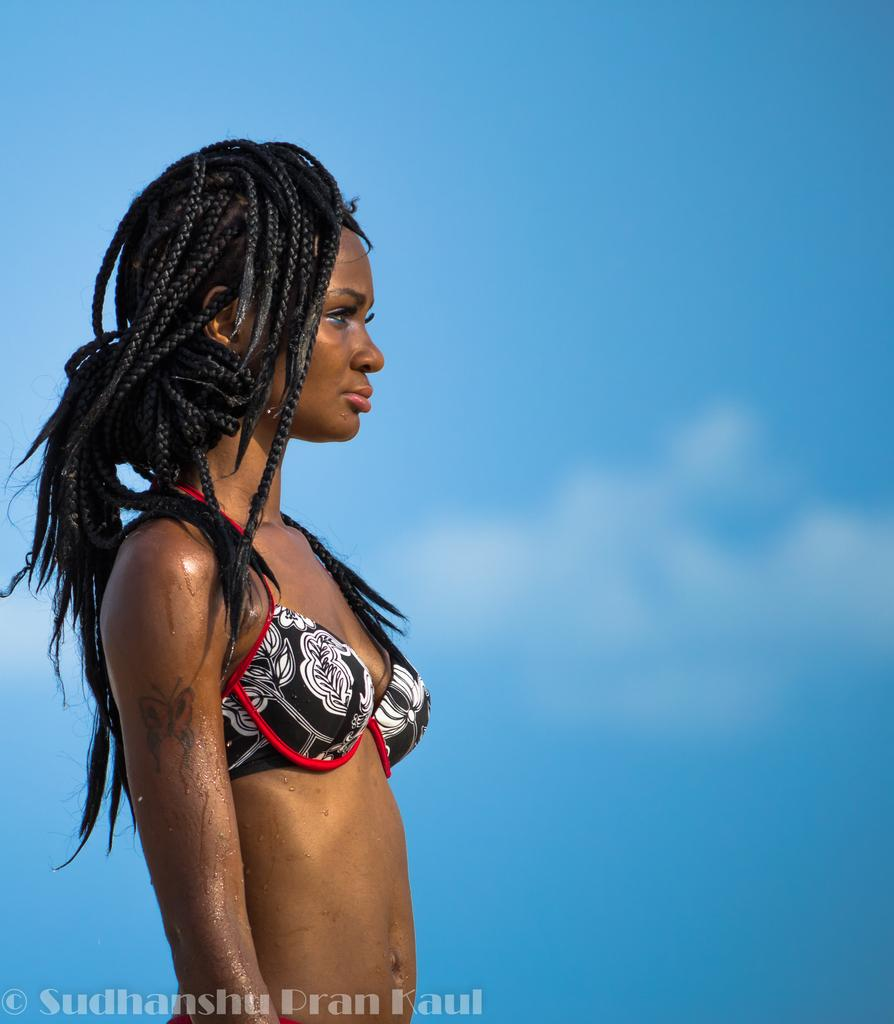What is the main subject of the image? There is a woman standing in the image. Can you describe any distinguishing features of the woman? The woman has a tattoo on her arm. What can be seen in the background of the image? The sky is visible in the background of the image. Where is the text located in the image? The text is in the bottom left corner of the image. How many leaves are on the woman's tattoo in the image? There is no mention of leaves in the image, as the woman has a tattoo, but no specific details about the tattoo are provided. 